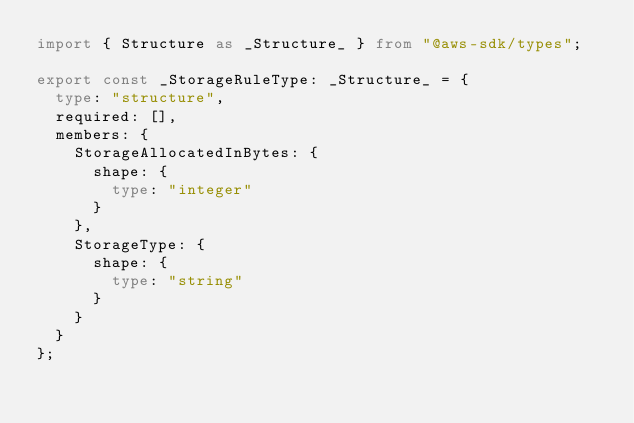Convert code to text. <code><loc_0><loc_0><loc_500><loc_500><_TypeScript_>import { Structure as _Structure_ } from "@aws-sdk/types";

export const _StorageRuleType: _Structure_ = {
  type: "structure",
  required: [],
  members: {
    StorageAllocatedInBytes: {
      shape: {
        type: "integer"
      }
    },
    StorageType: {
      shape: {
        type: "string"
      }
    }
  }
};
</code> 